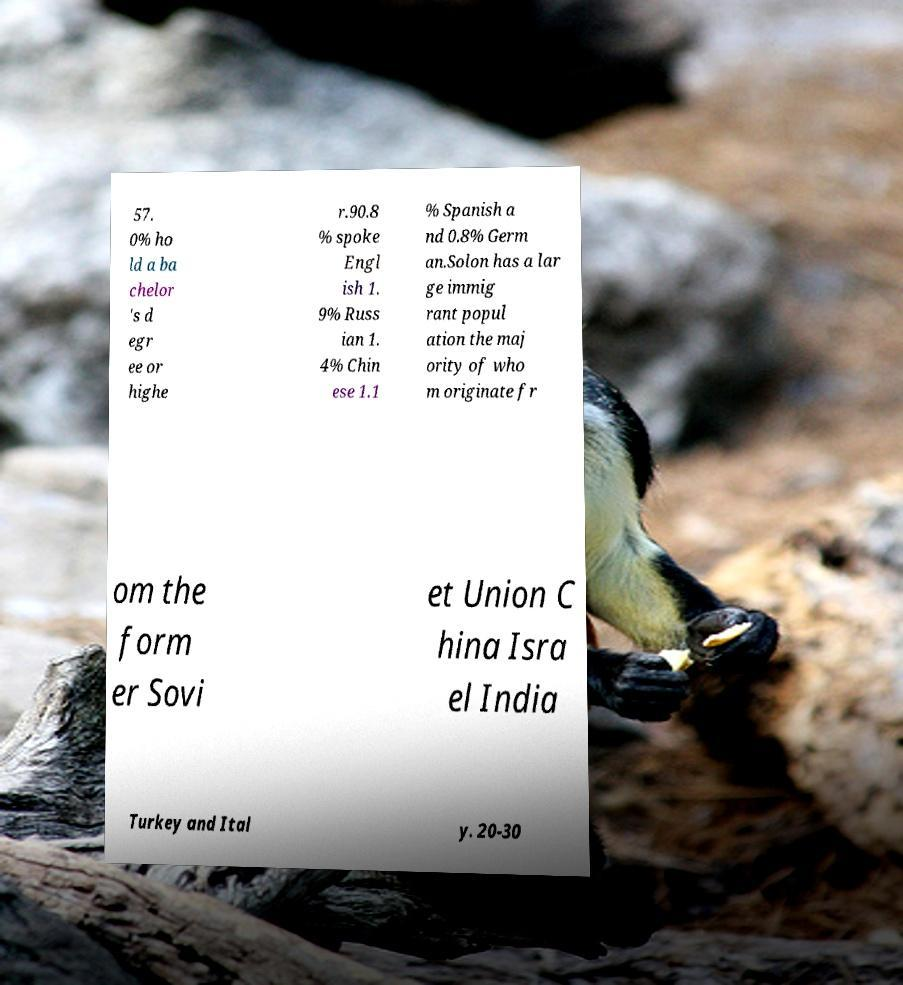Please identify and transcribe the text found in this image. 57. 0% ho ld a ba chelor 's d egr ee or highe r.90.8 % spoke Engl ish 1. 9% Russ ian 1. 4% Chin ese 1.1 % Spanish a nd 0.8% Germ an.Solon has a lar ge immig rant popul ation the maj ority of who m originate fr om the form er Sovi et Union C hina Isra el India Turkey and Ital y. 20-30 